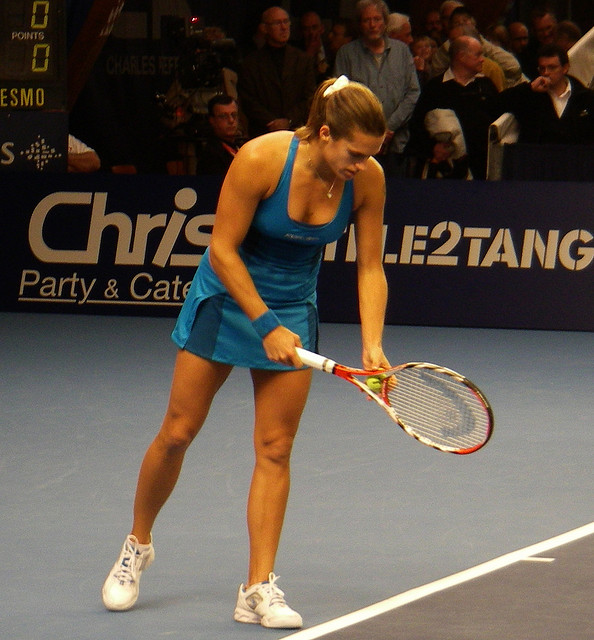Identify and read out the text in this image. ESMO S Party 0 POINTS 0 &amp; Cat LE2TANG Chris PARTY &amp; Cat 